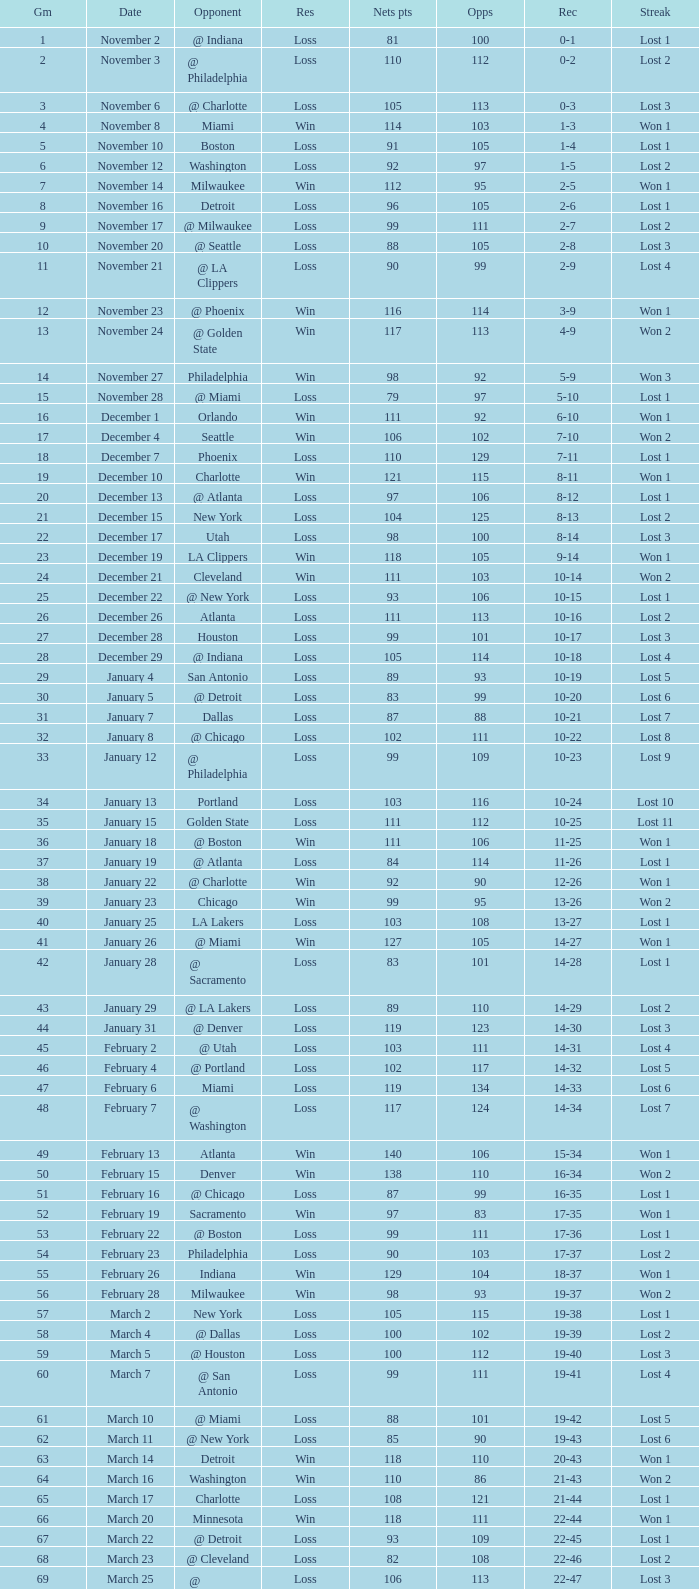What was the average point total for the nets in games before game 9 where the opponents scored less than 95? None. 